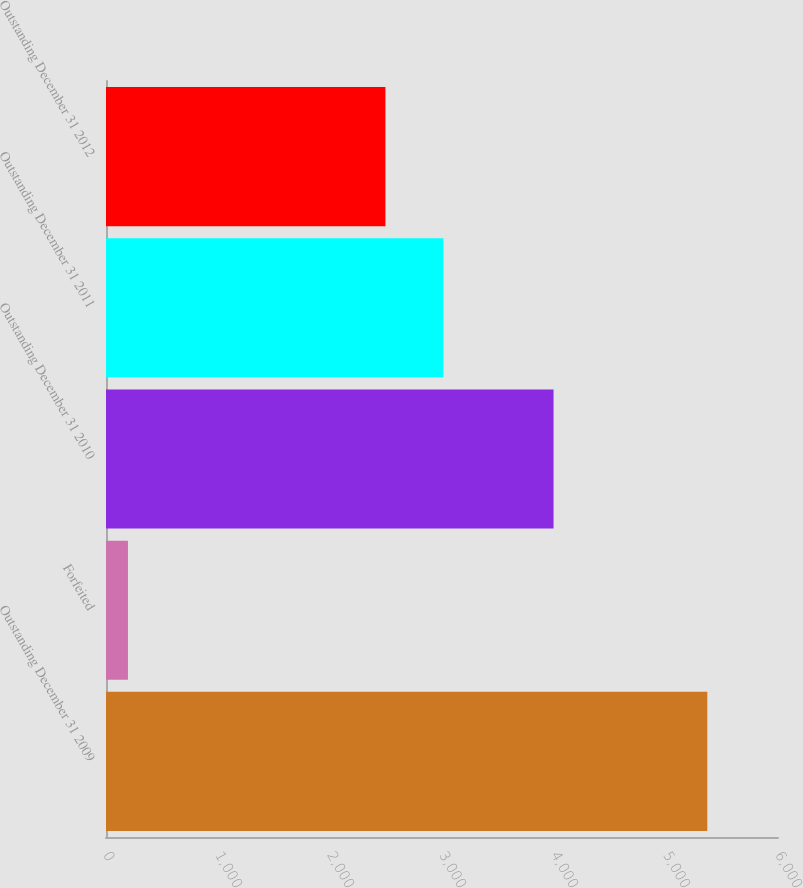Convert chart to OTSL. <chart><loc_0><loc_0><loc_500><loc_500><bar_chart><fcel>Outstanding December 31 2009<fcel>Forfeited<fcel>Outstanding December 31 2010<fcel>Outstanding December 31 2011<fcel>Outstanding December 31 2012<nl><fcel>5369<fcel>196<fcel>3996<fcel>3012.3<fcel>2495<nl></chart> 